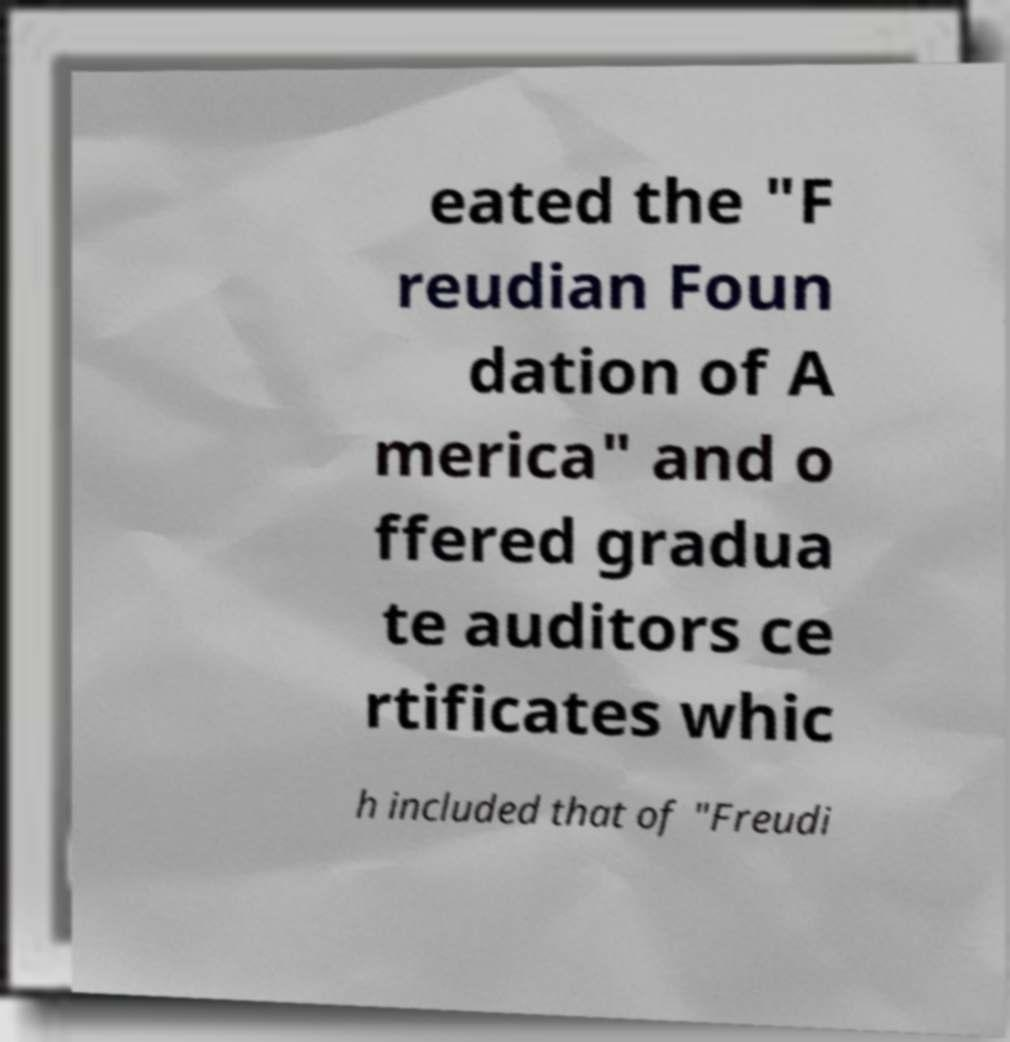Can you accurately transcribe the text from the provided image for me? eated the "F reudian Foun dation of A merica" and o ffered gradua te auditors ce rtificates whic h included that of "Freudi 